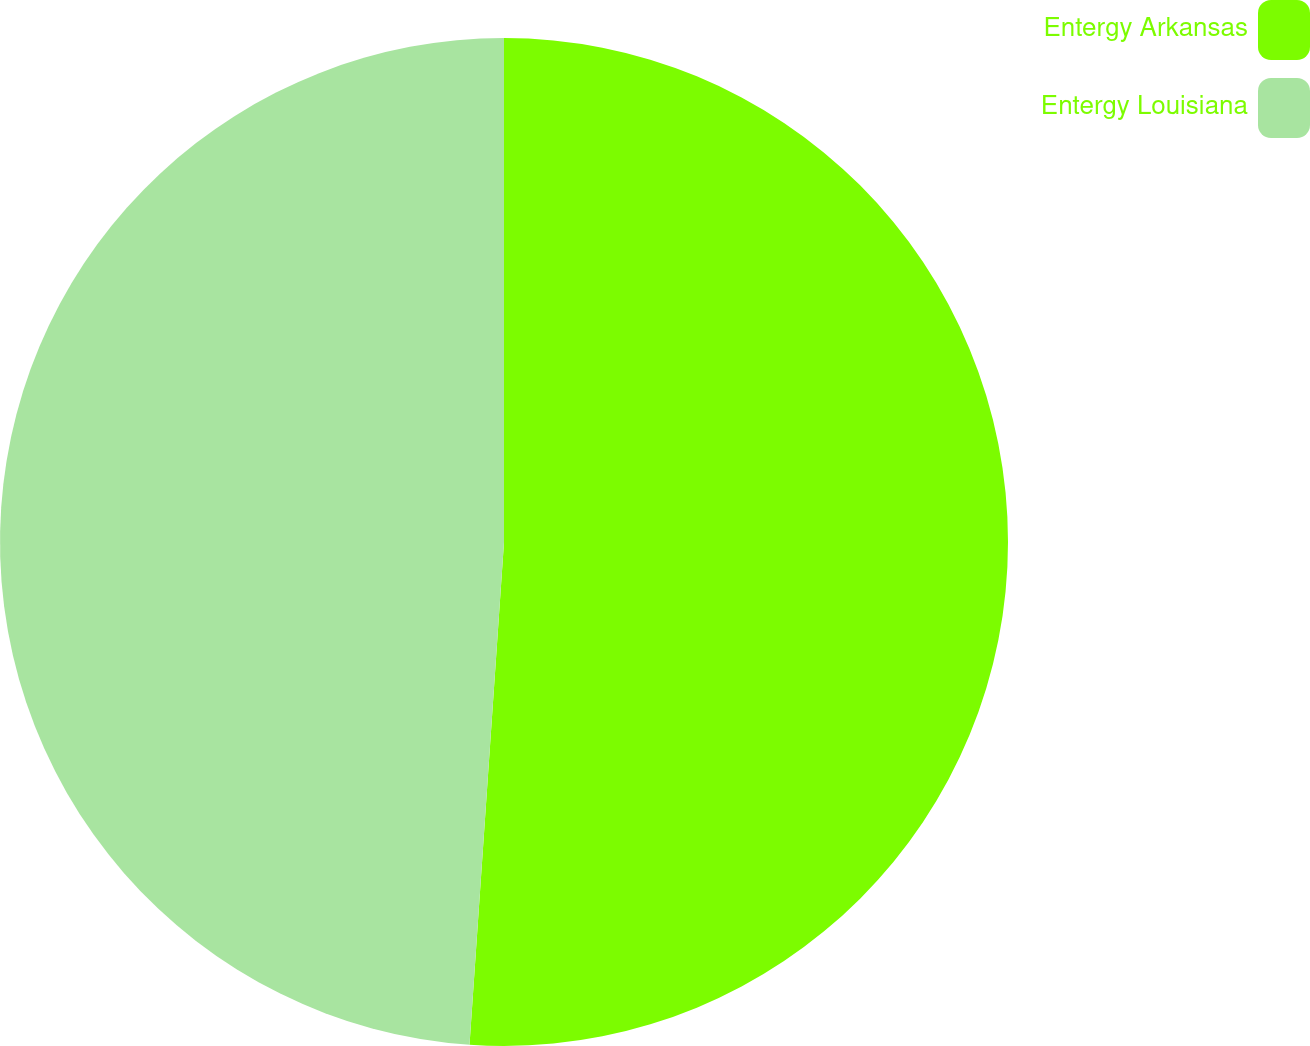Convert chart. <chart><loc_0><loc_0><loc_500><loc_500><pie_chart><fcel>Entergy Arkansas<fcel>Entergy Louisiana<nl><fcel>51.09%<fcel>48.91%<nl></chart> 